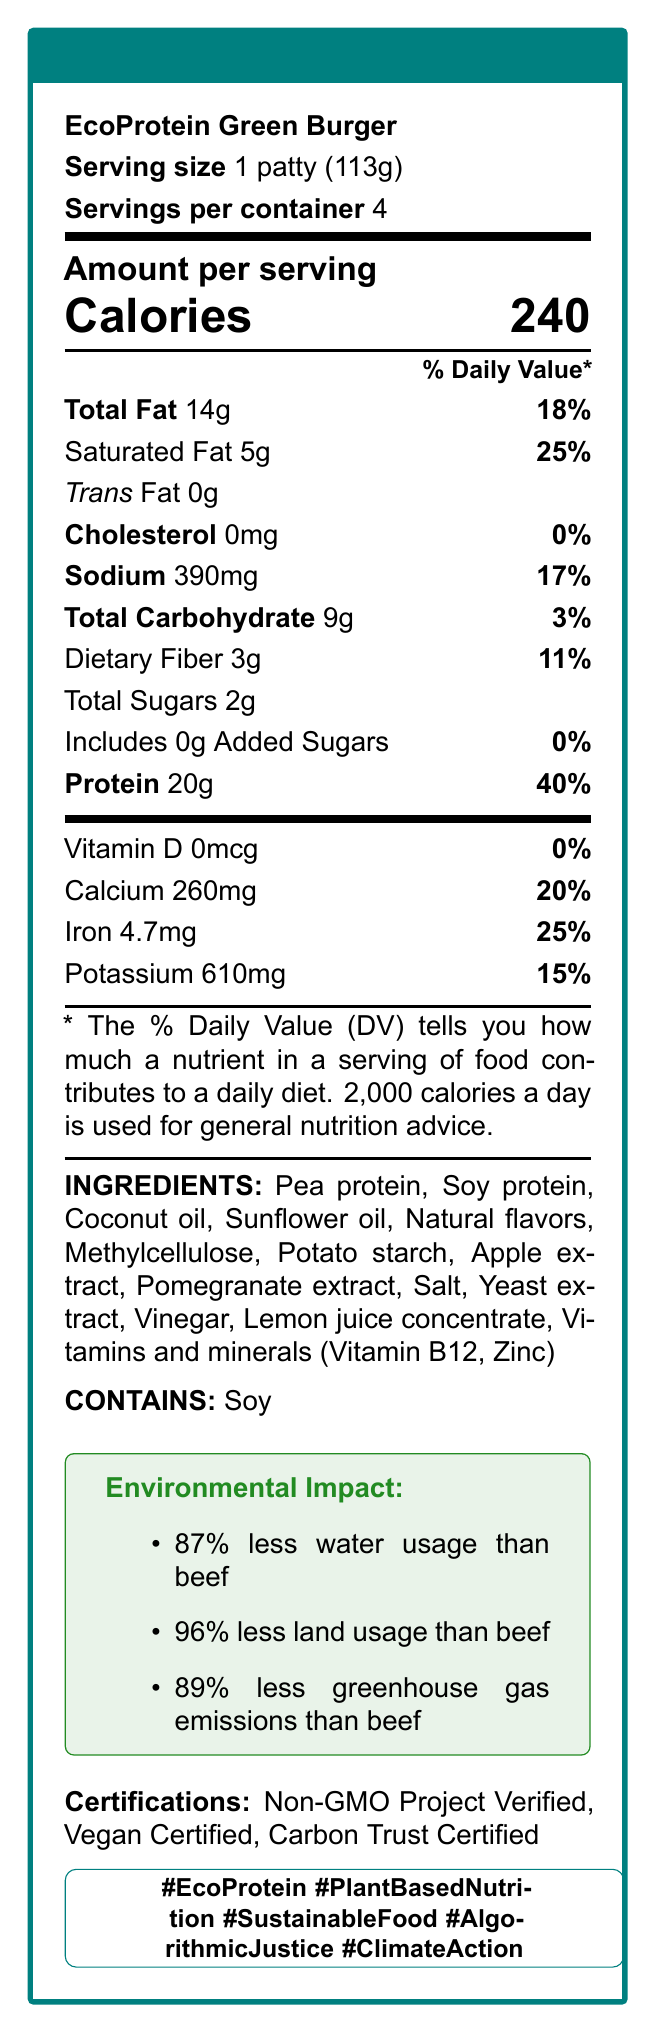What is the protein content per serving of the EcoProtein Green Burger? The Nutrition Facts label indicates that one serving, which is one patty, contains 20 grams of protein.
Answer: 20g How many servings are in one container? According to the label, there are 4 servings per container.
Answer: 4 What percentage of the daily value does the protein content represent? The label states that the protein content provides 40% of the daily value.
Answer: 40% What is the total fat content per serving? The Nutrition Facts label specifies that each serving contains 14 grams of total fat.
Answer: 14g How much sodium is in one serving? The Nutrition Facts label lists 390 milligrams of sodium per serving.
Answer: 390mg (Multiple-Choice) Which of the following certifications does the EcoProtein Green Burger have? A. Organic Certified B. Non-GMO Project Verified C. Gluten-Free The document lists "Non-GMO Project Verified" as one of the certifications.
Answer: B. Non-GMO Project Verified (Multiple-Choice) Which ingredient is a primary protein source in the EcoProtein Green Burger? 1. Coconut oil 2. Pea protein 3. Lemon juice concentrate 4. Vinegar Pea protein is listed as one of the primary ingredients and a primary protein source.
Answer: 2. Pea protein (True/False) The EcoProtein Green Burger contains added sugars. The label indicates that it contains 0 grams of added sugars.
Answer: False Describe the main idea of the EcoProtein Green Burger Nutrition Facts label. This explanation summarizes all the key points provided in the Nutrition Facts Label.
Answer: The EcoProtein Green Burger Nutrition Facts label provides detailed nutritional information for one serving (1 patty, 113g). It emphasizes high protein content (20g, 40% DV) and highlights environmental benefits compared to beef, including reduced water and land usage and lower greenhouse gas emissions. The product is certified Non-GMO, Vegan, and Carbon Trust Certified, and contains soy as an allergen. How much sugar is in one serving? The label states that there are 2 grams of total sugars per serving.
Answer: 2g Does the EcoProtein Green Burger contain any cholesterol? The Nutrition Facts label indicates 0 milligrams of cholesterol per serving.
Answer: No Which nutrient contributes 25% of the daily value per serving? Both saturated fat and iron contribute 25% of the daily value per serving.
Answer: Saturated Fat and Iron What is the purpose of the listed environmental benefits? The environmental impact section of the label states that the product uses significantly less water, land, and produces fewer greenhouse gas emissions than beef.
Answer: To highlight the reduced environmental impact compared to beef What are the main ingredients of the EcoProtein Green Burger? The label lists these as the main ingredients used in the product.
Answer: Pea protein, Soy protein, Coconut oil, Sunflower oil, Natural flavors, Methylcellulose, Potato starch, Apple extract, Pomegranate extract, Salt, Yeast extract, Vinegar, Lemon juice concentrate, Vitamins and minerals (Vitamin B12, Zinc) What is the caloric content per serving? According to the Nutrition Facts label, one serving contains 240 calories.
Answer: 240 calories Is the EcoProtein Green Burger gluten-free? The label does not provide any information regarding the presence or absence of gluten, so it is not possible to determine from the provided data.
Answer: Cannot be determined 